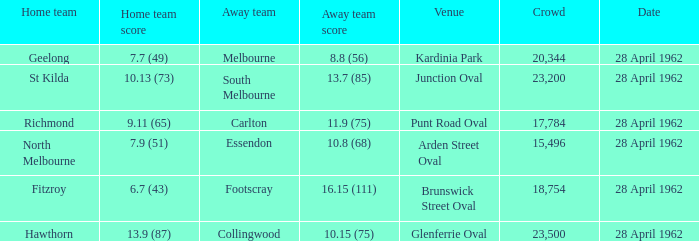What was the crowd size when there was a home team score of 10.13 (73)? 23200.0. 